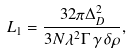<formula> <loc_0><loc_0><loc_500><loc_500>L _ { 1 } = \frac { 3 2 \pi \Delta ^ { 2 } _ { D } } { 3 N \lambda ^ { 2 } \Gamma \, \gamma \, \delta \rho } ,</formula> 